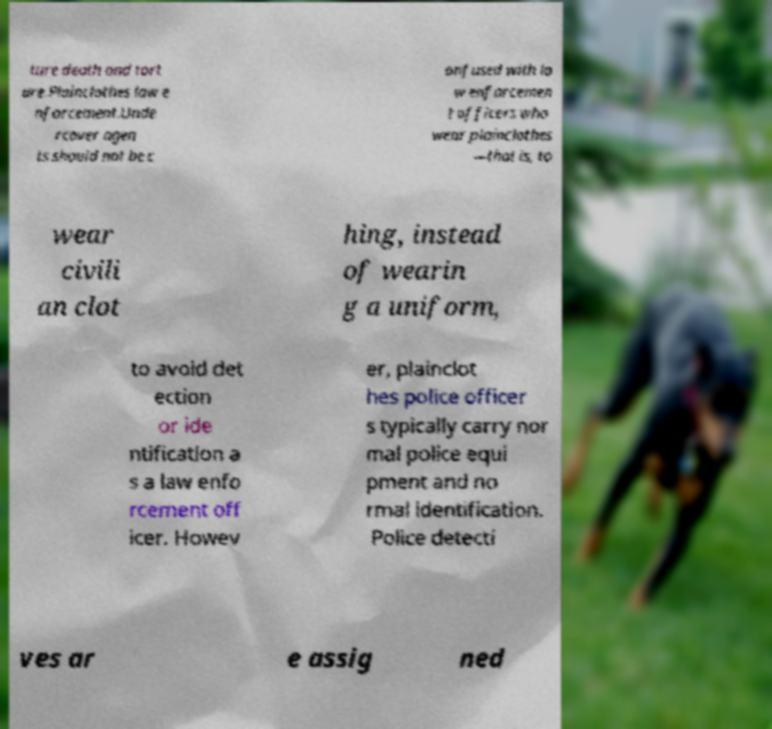There's text embedded in this image that I need extracted. Can you transcribe it verbatim? ture death and tort ure.Plainclothes law e nforcement.Unde rcover agen ts should not be c onfused with la w enforcemen t officers who wear plainclothes —that is, to wear civili an clot hing, instead of wearin g a uniform, to avoid det ection or ide ntification a s a law enfo rcement off icer. Howev er, plainclot hes police officer s typically carry nor mal police equi pment and no rmal identification. Police detecti ves ar e assig ned 